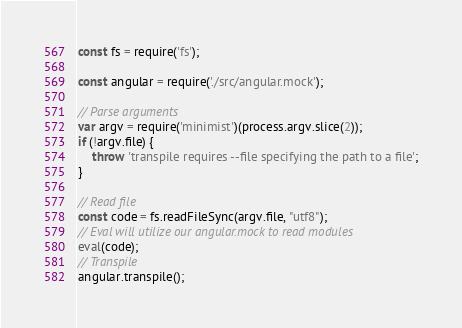Convert code to text. <code><loc_0><loc_0><loc_500><loc_500><_JavaScript_>const fs = require('fs');

const angular = require('./src/angular.mock');

// Parse arguments
var argv = require('minimist')(process.argv.slice(2));
if (!argv.file) {
    throw 'transpile requires --file specifying the path to a file';
}

// Read file
const code = fs.readFileSync(argv.file, "utf8");
// Eval will utilize our angular.mock to read modules
eval(code);
// Transpile
angular.transpile();
</code> 